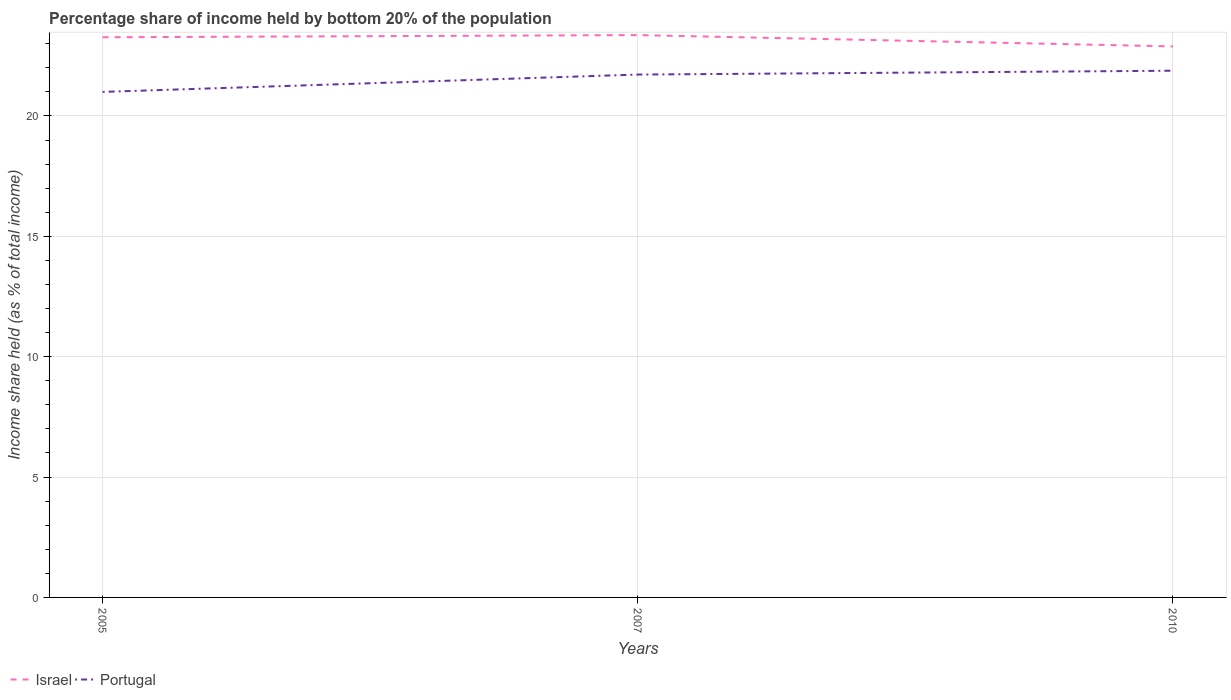Does the line corresponding to Portugal intersect with the line corresponding to Israel?
Offer a very short reply. No. What is the total share of income held by bottom 20% of the population in Portugal in the graph?
Offer a terse response. -0.88. What is the difference between the highest and the second highest share of income held by bottom 20% of the population in Israel?
Offer a very short reply. 0.47. What is the difference between two consecutive major ticks on the Y-axis?
Provide a short and direct response. 5. Are the values on the major ticks of Y-axis written in scientific E-notation?
Offer a terse response. No. Does the graph contain any zero values?
Your response must be concise. No. Does the graph contain grids?
Keep it short and to the point. Yes. How are the legend labels stacked?
Offer a terse response. Horizontal. What is the title of the graph?
Provide a succinct answer. Percentage share of income held by bottom 20% of the population. Does "Liberia" appear as one of the legend labels in the graph?
Your answer should be very brief. No. What is the label or title of the X-axis?
Provide a short and direct response. Years. What is the label or title of the Y-axis?
Provide a short and direct response. Income share held (as % of total income). What is the Income share held (as % of total income) in Israel in 2005?
Make the answer very short. 23.27. What is the Income share held (as % of total income) of Israel in 2007?
Keep it short and to the point. 23.36. What is the Income share held (as % of total income) in Portugal in 2007?
Provide a short and direct response. 21.72. What is the Income share held (as % of total income) in Israel in 2010?
Offer a very short reply. 22.89. What is the Income share held (as % of total income) in Portugal in 2010?
Provide a succinct answer. 21.88. Across all years, what is the maximum Income share held (as % of total income) of Israel?
Give a very brief answer. 23.36. Across all years, what is the maximum Income share held (as % of total income) in Portugal?
Make the answer very short. 21.88. Across all years, what is the minimum Income share held (as % of total income) of Israel?
Give a very brief answer. 22.89. Across all years, what is the minimum Income share held (as % of total income) in Portugal?
Give a very brief answer. 21. What is the total Income share held (as % of total income) in Israel in the graph?
Offer a very short reply. 69.52. What is the total Income share held (as % of total income) of Portugal in the graph?
Your answer should be very brief. 64.6. What is the difference between the Income share held (as % of total income) in Israel in 2005 and that in 2007?
Your response must be concise. -0.09. What is the difference between the Income share held (as % of total income) of Portugal in 2005 and that in 2007?
Ensure brevity in your answer.  -0.72. What is the difference between the Income share held (as % of total income) of Israel in 2005 and that in 2010?
Your response must be concise. 0.38. What is the difference between the Income share held (as % of total income) in Portugal in 2005 and that in 2010?
Provide a short and direct response. -0.88. What is the difference between the Income share held (as % of total income) in Israel in 2007 and that in 2010?
Your response must be concise. 0.47. What is the difference between the Income share held (as % of total income) in Portugal in 2007 and that in 2010?
Keep it short and to the point. -0.16. What is the difference between the Income share held (as % of total income) in Israel in 2005 and the Income share held (as % of total income) in Portugal in 2007?
Provide a short and direct response. 1.55. What is the difference between the Income share held (as % of total income) in Israel in 2005 and the Income share held (as % of total income) in Portugal in 2010?
Provide a short and direct response. 1.39. What is the difference between the Income share held (as % of total income) of Israel in 2007 and the Income share held (as % of total income) of Portugal in 2010?
Ensure brevity in your answer.  1.48. What is the average Income share held (as % of total income) of Israel per year?
Your answer should be very brief. 23.17. What is the average Income share held (as % of total income) of Portugal per year?
Your answer should be very brief. 21.53. In the year 2005, what is the difference between the Income share held (as % of total income) in Israel and Income share held (as % of total income) in Portugal?
Offer a terse response. 2.27. In the year 2007, what is the difference between the Income share held (as % of total income) in Israel and Income share held (as % of total income) in Portugal?
Offer a terse response. 1.64. What is the ratio of the Income share held (as % of total income) of Israel in 2005 to that in 2007?
Provide a succinct answer. 1. What is the ratio of the Income share held (as % of total income) in Portugal in 2005 to that in 2007?
Provide a short and direct response. 0.97. What is the ratio of the Income share held (as % of total income) in Israel in 2005 to that in 2010?
Your response must be concise. 1.02. What is the ratio of the Income share held (as % of total income) in Portugal in 2005 to that in 2010?
Provide a short and direct response. 0.96. What is the ratio of the Income share held (as % of total income) of Israel in 2007 to that in 2010?
Keep it short and to the point. 1.02. What is the ratio of the Income share held (as % of total income) of Portugal in 2007 to that in 2010?
Provide a short and direct response. 0.99. What is the difference between the highest and the second highest Income share held (as % of total income) in Israel?
Provide a short and direct response. 0.09. What is the difference between the highest and the second highest Income share held (as % of total income) in Portugal?
Provide a short and direct response. 0.16. What is the difference between the highest and the lowest Income share held (as % of total income) in Israel?
Make the answer very short. 0.47. 